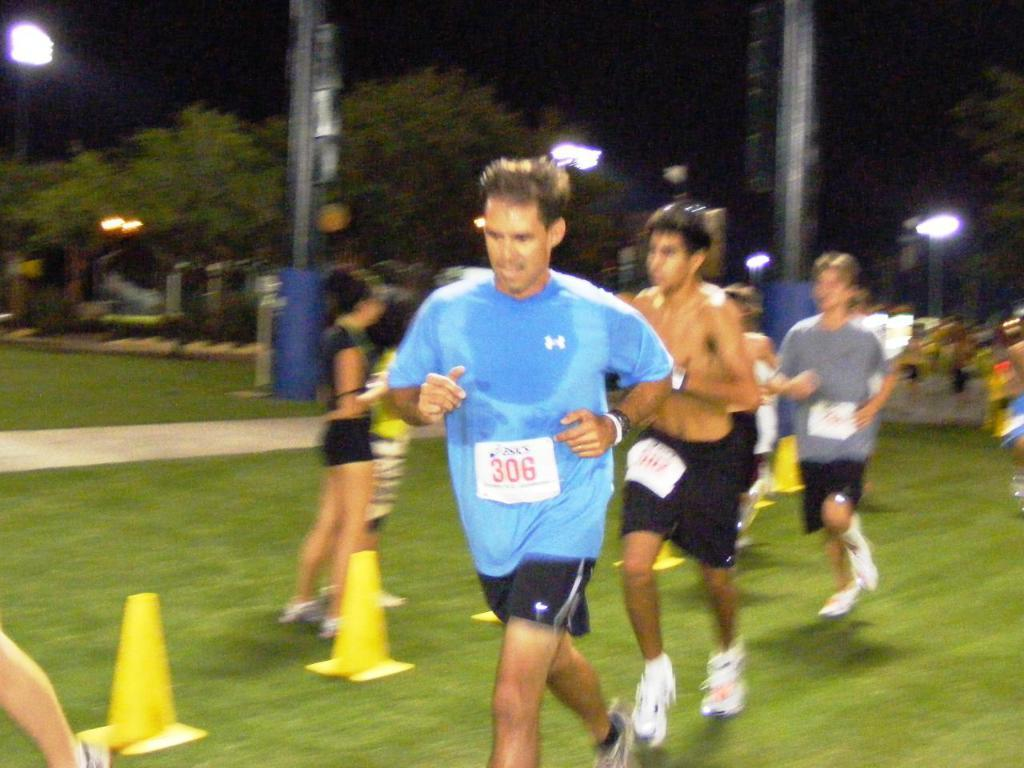How many people are in the image? There is a group of persons in the image. What are the persons in the image doing? The persons are running. On what type of surface are the persons running? The running is taking place on a grassy land. What can be seen in the background of the image? There are trees in the background of the image. What type of feather can be seen falling from the sky in the image? There is no feather falling from the sky in the image. Is there a bomb visible in the image? There is no bomb present in the image. 